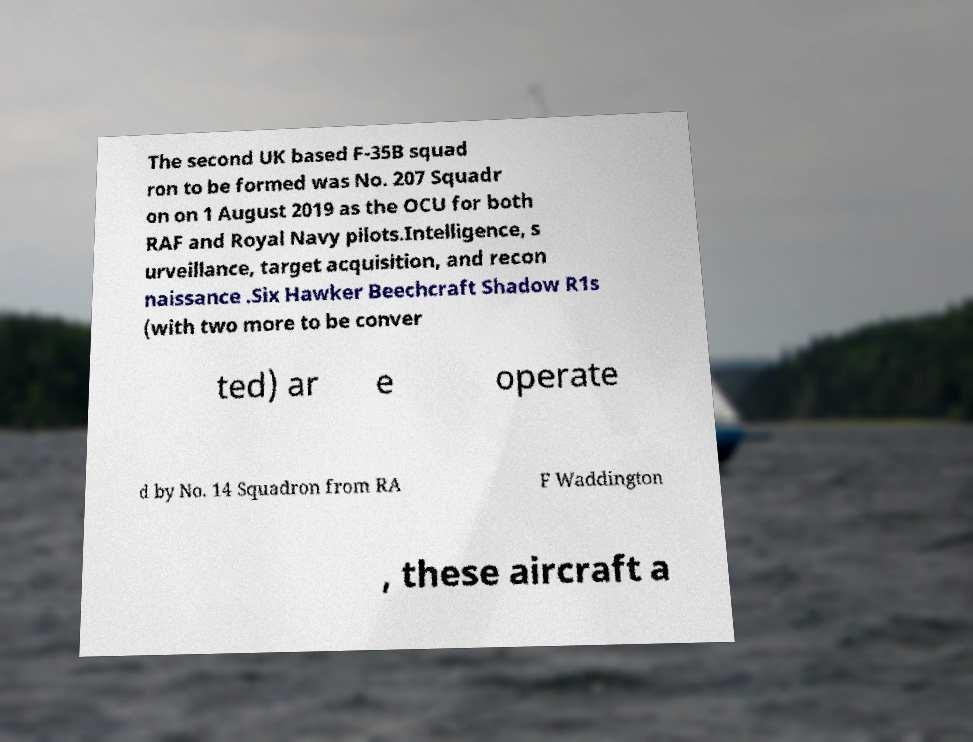Can you read and provide the text displayed in the image?This photo seems to have some interesting text. Can you extract and type it out for me? The second UK based F-35B squad ron to be formed was No. 207 Squadr on on 1 August 2019 as the OCU for both RAF and Royal Navy pilots.Intelligence, s urveillance, target acquisition, and recon naissance .Six Hawker Beechcraft Shadow R1s (with two more to be conver ted) ar e operate d by No. 14 Squadron from RA F Waddington , these aircraft a 